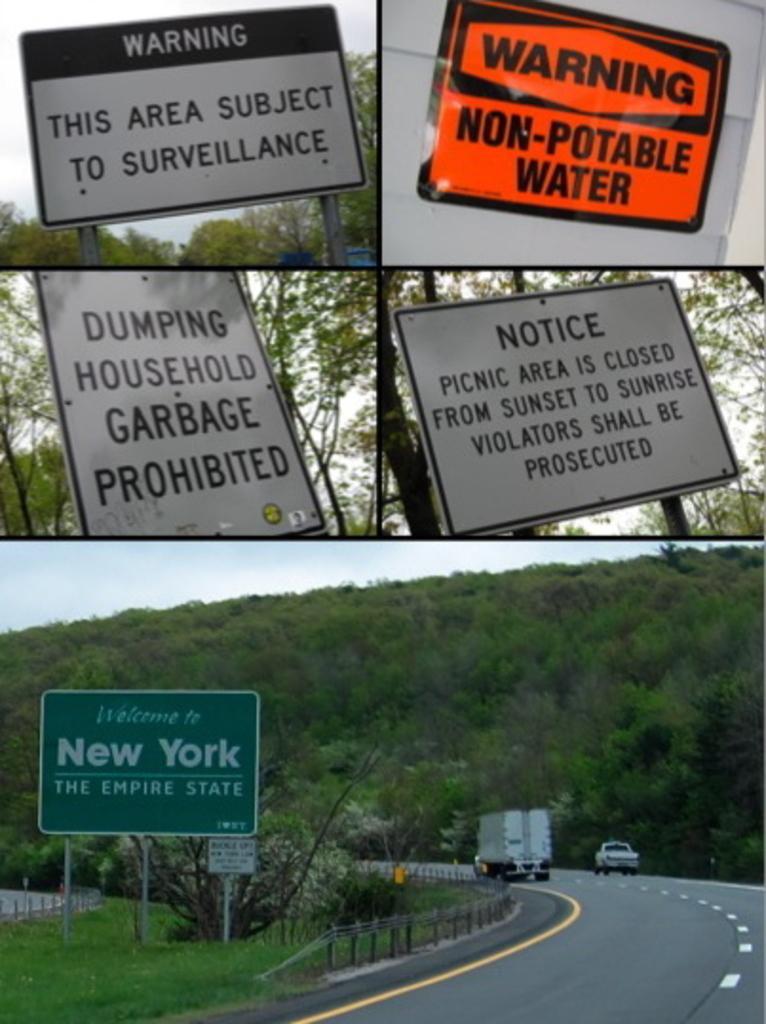Please provide a concise description of this image. This is a collage picture and in this picture we can see sign boards, name board, vehicles on the road, trees, fence and in the background we can see the sky. 